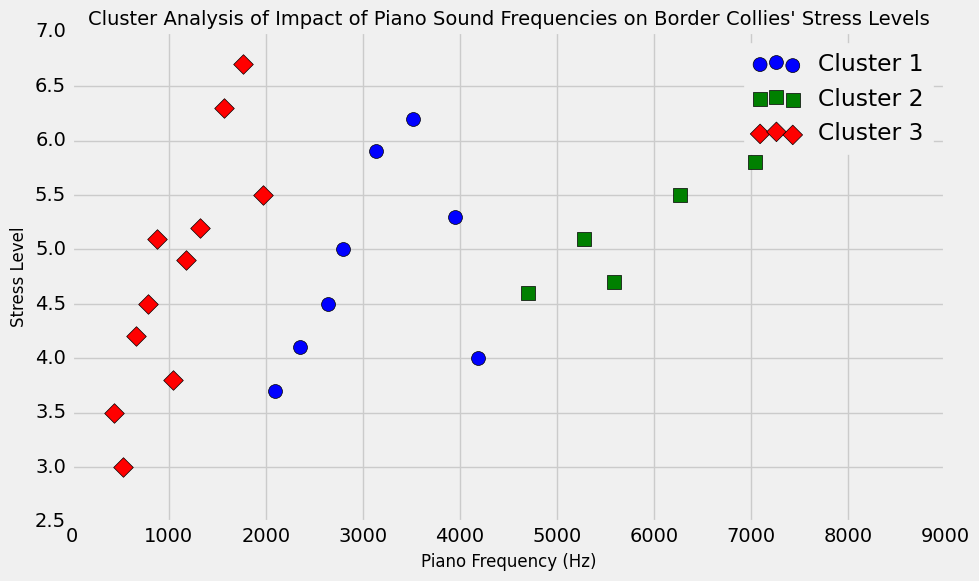What is the mean stress level for the border collies across all clusters? To find the mean stress level, sum up all the stress levels and then divide by the number of data points. The sum of all stress levels is 112.5 and there are 25 data points, so the mean is 112.5/25 = 4.5.
Answer: 4.5 Which cluster has the highest overall stress levels for the frequencies tested? By examining the plot, look at the average positions of the data points in each cluster. Cluster 3 (the red mark) appears to have generally higher stress levels.
Answer: Cluster 3 What is the difference in stress levels between the border collies' responses at 440 Hz and 1046.5 Hz? According to the data, the stress level at 440 Hz is 3.5 and at 1046.5 Hz is 3.8. The difference is 3.8 - 3.5 = 0.3.
Answer: 0.3 Which cluster contains the highest number of data points? Look at the number of data points (markers) in each cluster within the plot. Cluster 2 (the green markers) visibly has the most data points.
Answer: Cluster 2 What is the closest piano frequency where the stress level is highest? Check the data points in the plot for the highest stress level and find the corresponding frequency. The highest stress level is 6.7 at 1760 Hz.
Answer: 1760 Hz Is there a trend of increasing stress levels with increasing frequencies within a specific cluster? By observing the cluster markers, you can see if there is a general upward or downward trend. Most clusters, especially Cluster 3, show an increase in stress level with higher frequencies.
Answer: Yes Among the clusters, which has the lowest stress level recorded and at what frequency? Check the lowest position (along the stress level axis) for each cluster in the plot. The lowest stress level, 3.0, is found in Cluster 1 at 523.25 Hz.
Answer: Cluster 1, 523.25 Hz What is the average frequency of Cluster 2? Sum up the frequencies of the data points in Cluster 2 and divide by the number of points in that cluster.
Answer: The detailed calculation involves identifying each data point in Cluster 2 and summing their frequencies, then dividing by their count. For instance, Cluster 2 points are roughly around: 659.25, 783.99, 880, etc. The total sum divided by the count provides the average. Plug in the specific values to find the answer Is there a frequency range where multiple clusters overlap? Look at the horizontal span of each cluster (frequency axis) to see where markers from different clusters are clustered together. Frequencies between approx. 500 to 3000 Hz see overlapping clusters.
Answer: Yes, approx. 500 to 3000 Hz 